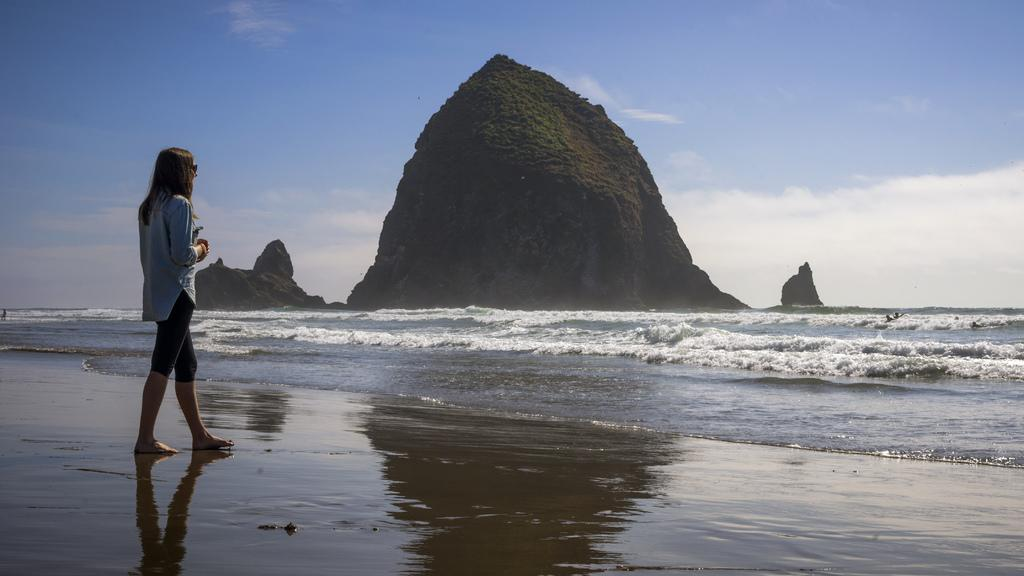Who is present in the image? There is a woman in the image. What is the woman wearing? The woman is wearing a blue dress. What is the woman doing in the image? The woman is standing. What can be seen in the background of the image? There is water and a mountain visible in the image. Are there any other people in the image? Yes, there are people in the water in the right corner of the image. What type of tools does the carpenter use in the image? There is no carpenter present in the image, so no tools can be observed. What kind of crops are being harvested by the farmer in the image? There is no farmer present in the image, so no crops can be observed. 